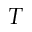<formula> <loc_0><loc_0><loc_500><loc_500>T</formula> 